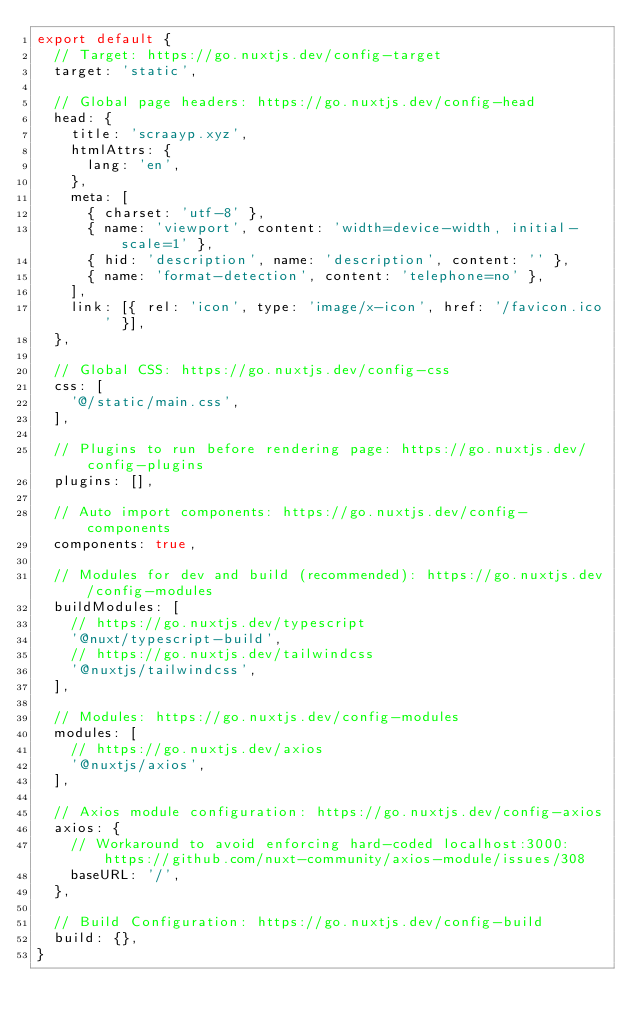Convert code to text. <code><loc_0><loc_0><loc_500><loc_500><_JavaScript_>export default {
  // Target: https://go.nuxtjs.dev/config-target
  target: 'static',

  // Global page headers: https://go.nuxtjs.dev/config-head
  head: {
    title: 'scraayp.xyz',
    htmlAttrs: {
      lang: 'en',
    },
    meta: [
      { charset: 'utf-8' },
      { name: 'viewport', content: 'width=device-width, initial-scale=1' },
      { hid: 'description', name: 'description', content: '' },
      { name: 'format-detection', content: 'telephone=no' },
    ],
    link: [{ rel: 'icon', type: 'image/x-icon', href: '/favicon.ico' }],
  },

  // Global CSS: https://go.nuxtjs.dev/config-css
  css: [
    '@/static/main.css',
  ],

  // Plugins to run before rendering page: https://go.nuxtjs.dev/config-plugins
  plugins: [],

  // Auto import components: https://go.nuxtjs.dev/config-components
  components: true,

  // Modules for dev and build (recommended): https://go.nuxtjs.dev/config-modules
  buildModules: [
    // https://go.nuxtjs.dev/typescript
    '@nuxt/typescript-build',
    // https://go.nuxtjs.dev/tailwindcss
    '@nuxtjs/tailwindcss',
  ],

  // Modules: https://go.nuxtjs.dev/config-modules
  modules: [
    // https://go.nuxtjs.dev/axios
    '@nuxtjs/axios',
  ],

  // Axios module configuration: https://go.nuxtjs.dev/config-axios
  axios: {
    // Workaround to avoid enforcing hard-coded localhost:3000: https://github.com/nuxt-community/axios-module/issues/308
    baseURL: '/',
  },

  // Build Configuration: https://go.nuxtjs.dev/config-build
  build: {},
}
</code> 